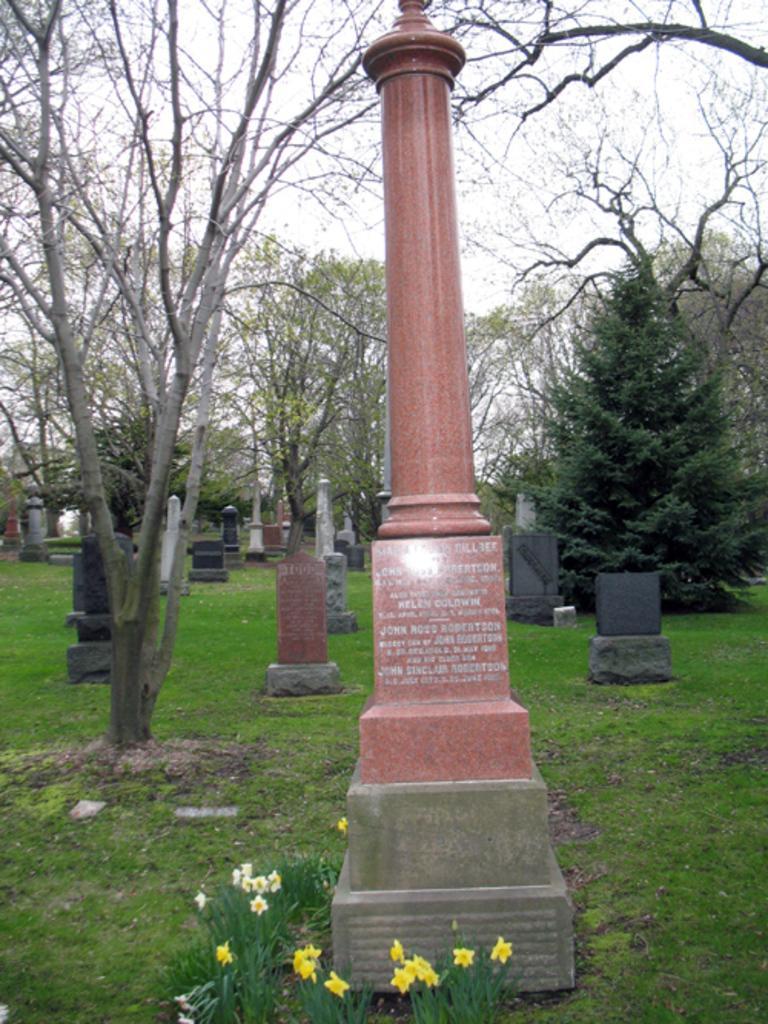In one or two sentences, can you explain what this image depicts? The picture is taken in the cemetery. In the picture there are gravestones, plants, flowers and trees. Sky is cloudy. 